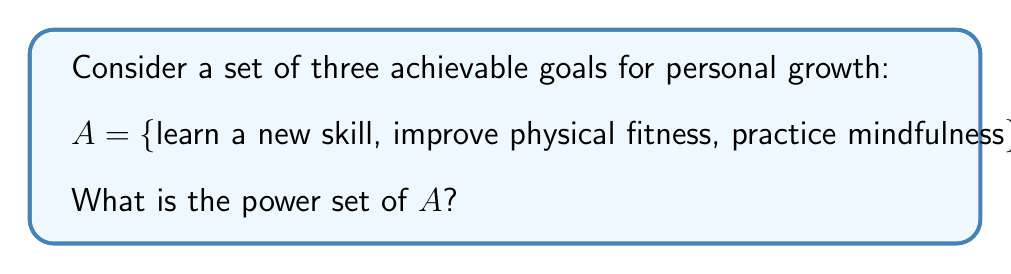Can you solve this math problem? To solve this problem, let's break it down step-by-step:

1. Recall that the power set of a set A, denoted as P(A), is the set of all possible subsets of A, including the empty set and A itself.

2. For a set with n elements, the number of elements in its power set is $2^n$.

3. In this case, our set A has 3 elements, so the power set will have $2^3 = 8$ elements.

4. To list all the subsets, we can systematically consider all combinations:

   - The empty set: $\{\}$
   - Subsets with 1 element: {learn a new skill}, {improve physical fitness}, {practice mindfulness}
   - Subsets with 2 elements: {learn a new skill, improve physical fitness}, {learn a new skill, practice mindfulness}, {improve physical fitness, practice mindfulness}
   - The full set: {learn a new skill, improve physical fitness, practice mindfulness}

5. The power set is the collection of all these subsets.

This approach allows us to methodically identify all possible combinations of goals, which can be particularly useful for planning and prioritizing personal growth objectives.
Answer: The power set of A is:

P(A) = {$\{\}$, {learn a new skill}, {improve physical fitness}, {practice mindfulness}, {learn a new skill, improve physical fitness}, {learn a new skill, practice mindfulness}, {improve physical fitness, practice mindfulness}, {learn a new skill, improve physical fitness, practice mindfulness}} 